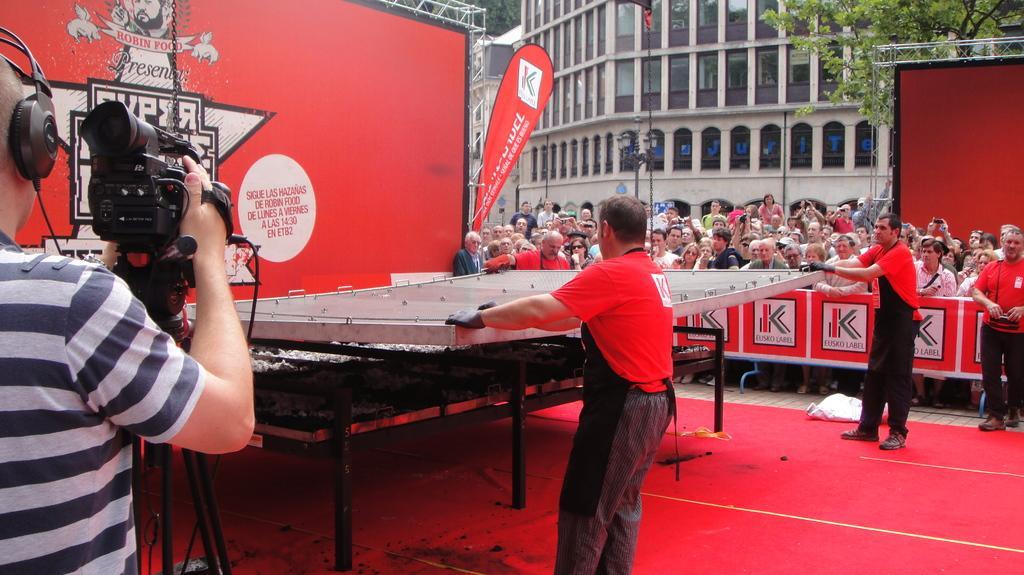Describe this image in one or two sentences. In this picture there are people, among them there are three men holding a metal object and there is a man holding a camera and wired headset, under the meta object we can see cot. We can see hoardings, rods and banner. In the background of the image we can see trees, poles and buildings. 